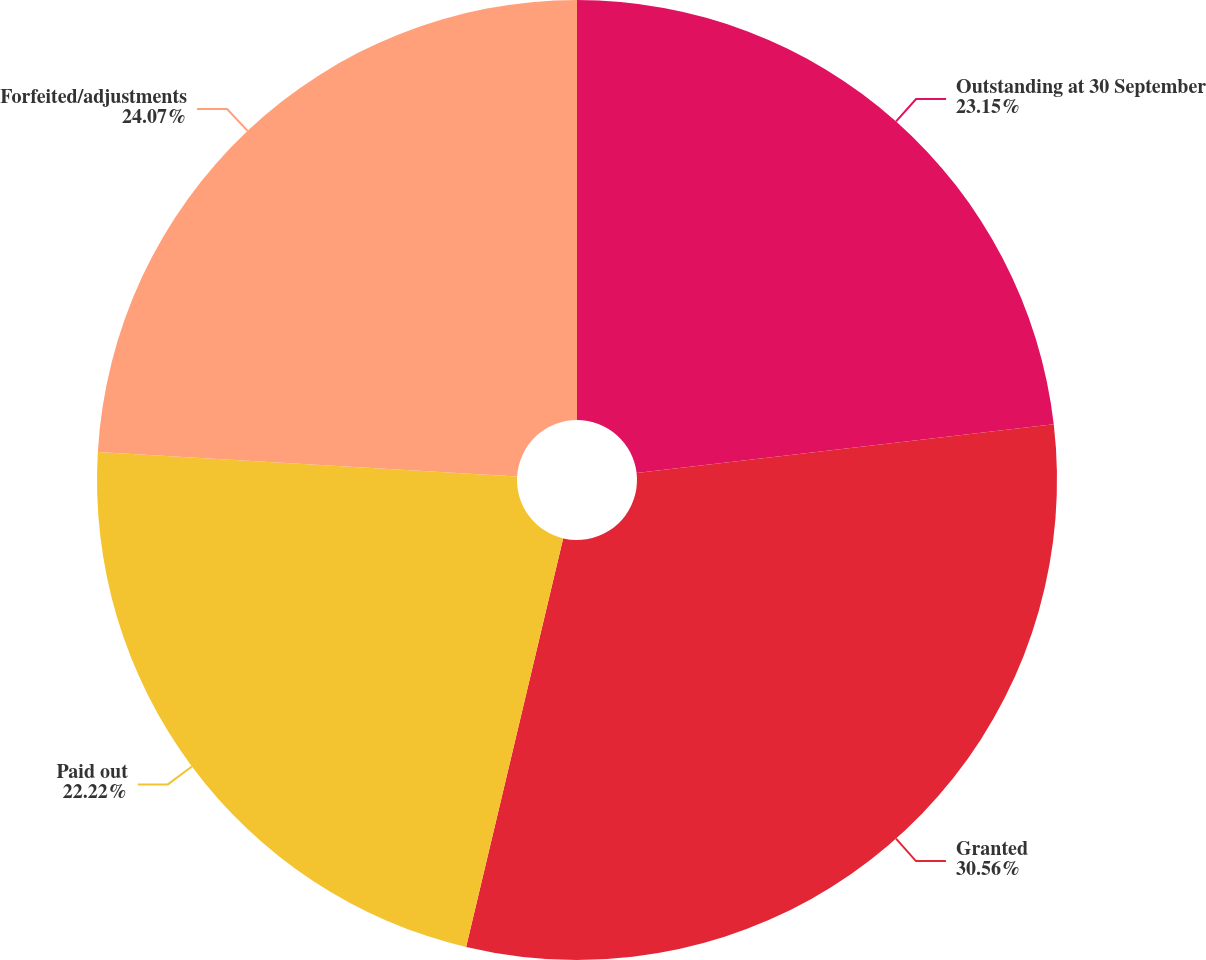<chart> <loc_0><loc_0><loc_500><loc_500><pie_chart><fcel>Outstanding at 30 September<fcel>Granted<fcel>Paid out<fcel>Forfeited/adjustments<nl><fcel>23.15%<fcel>30.56%<fcel>22.22%<fcel>24.07%<nl></chart> 